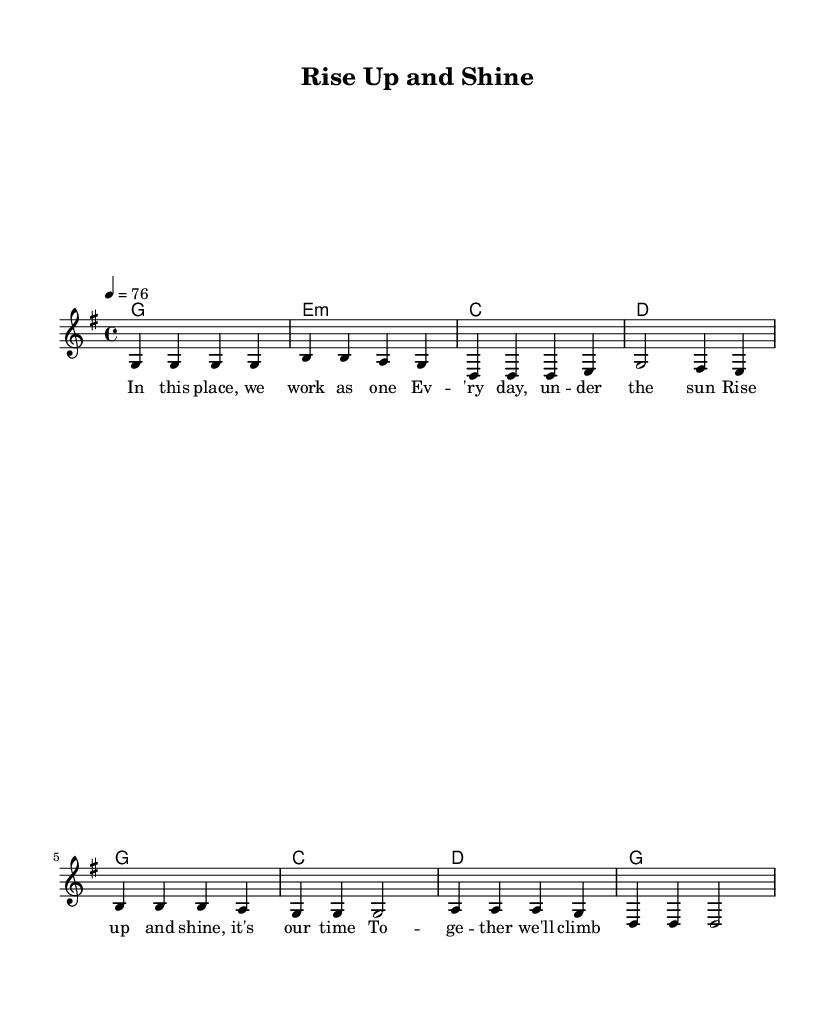What is the key signature of this music? The key signature is indicated by the presence of one sharp on the staff which corresponds to G major.
Answer: G major What is the time signature of this music? The time signature is shown at the beginning of the staff as 4/4, indicating four beats per measure.
Answer: 4/4 What is the tempo marking in this piece? The tempo marking is found at the beginning, stating “4 = 76,” which means there are 76 beats per minute.
Answer: 76 What is the first chord played in the verse? The first chord is represented at the beginning of the verse section, shown as G in chord notation.
Answer: G How many measures are in the chorus of the song? The chorus consists of four measures as indicated by the grouping of notes and chords specifically laid out in that section.
Answer: 4 What is the lyrical theme identified in this song? The lyrics denote a motivational and uplifting theme, focusing on unity and collective effort, as reflected in phrases like “Rise up and shine."
Answer: Unity How does the chorus differentiate from the verse musically? The chorus has a different melodic focus with repeated notes, contrasting with the verse's more varied melody. The harmonic structure also shifts to emphasize different chords.
Answer: Repetition and shifting harmonies 